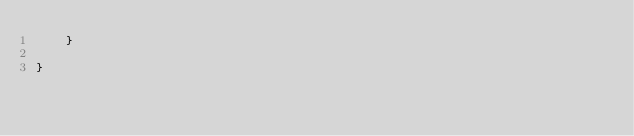<code> <loc_0><loc_0><loc_500><loc_500><_Java_>    }

}
</code> 